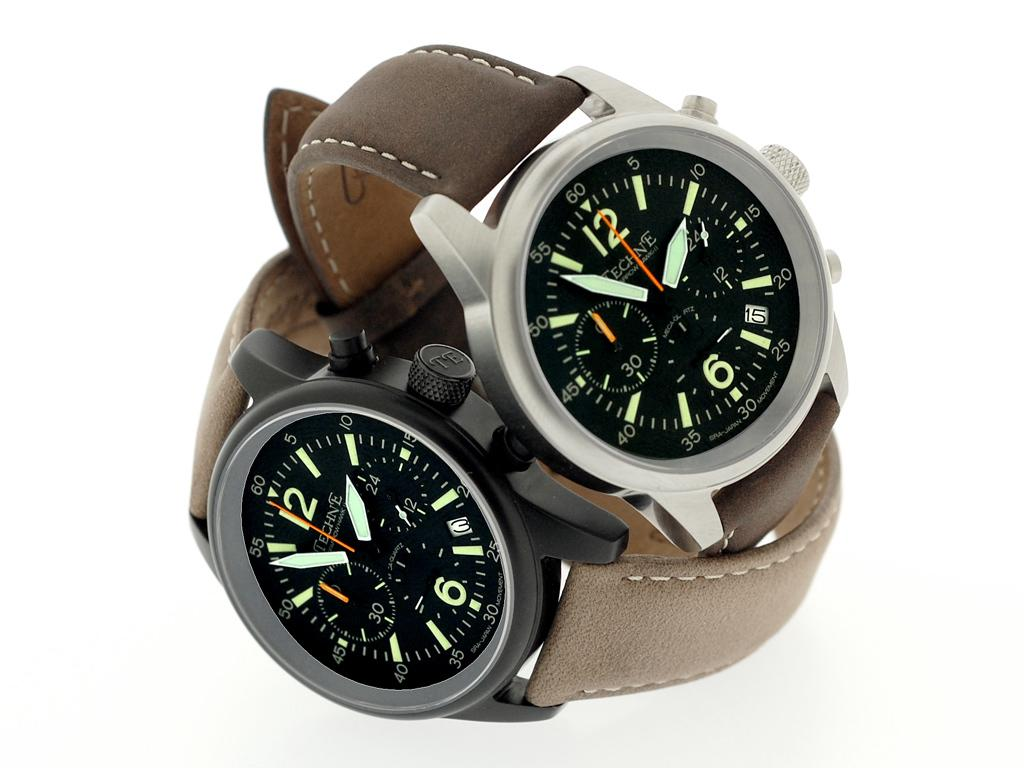<image>
Summarize the visual content of the image. Two watches are on top of each other with the top one reading almost 1:55. 